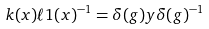<formula> <loc_0><loc_0><loc_500><loc_500>k ( x ) \ell 1 ( x ) ^ { - 1 } = \delta ( g ) y \delta ( g ) ^ { - 1 }</formula> 